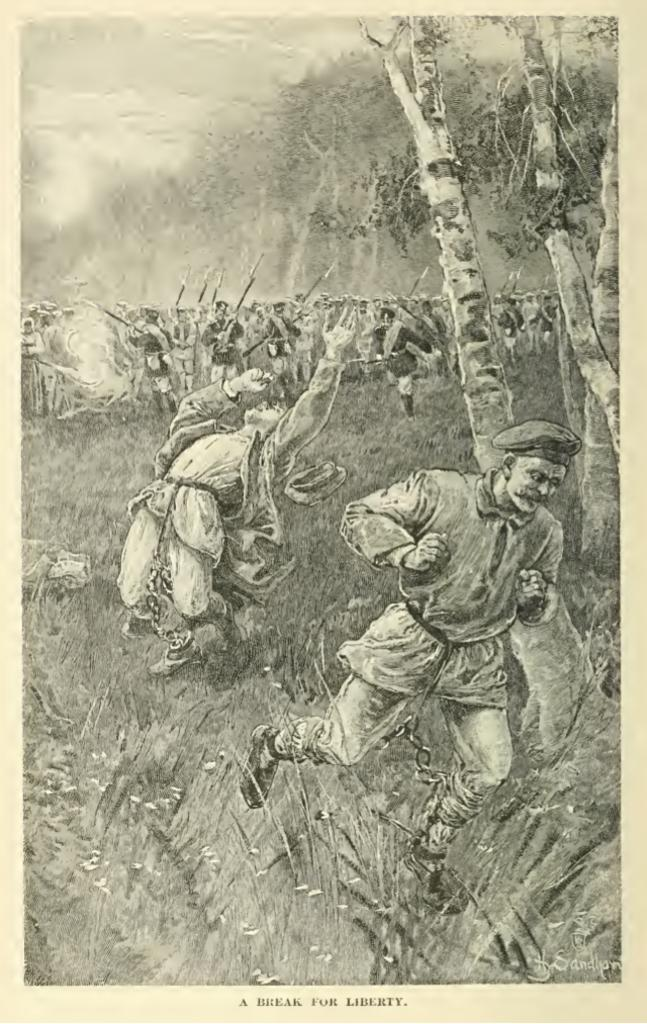<image>
Share a concise interpretation of the image provided. An old poster of men running for soldiers with guns that says A Break For Liberty at the bottom. 